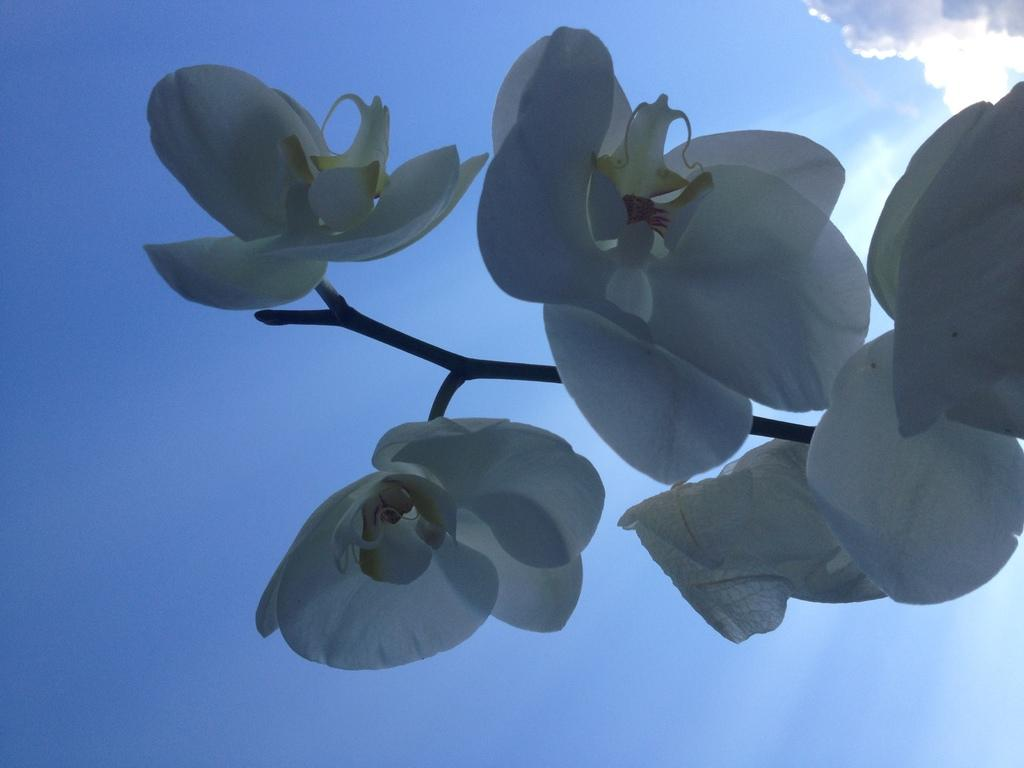Where was the picture taken? The picture was clicked outside. What is the main subject of the image? There is a group of white color flowers in the center of the image. What part of the flowers can be seen in the image? The flowers have stems. What can be seen in the background of the image? There is a sky visible in the background of the image. What is the weather like in the image? The presence of clouds in the sky suggests that it might be partly cloudy. How many dogs are playing with the parcel in the image? There are no dogs or parcels present in the image; it features a group of white color flowers with stems. 